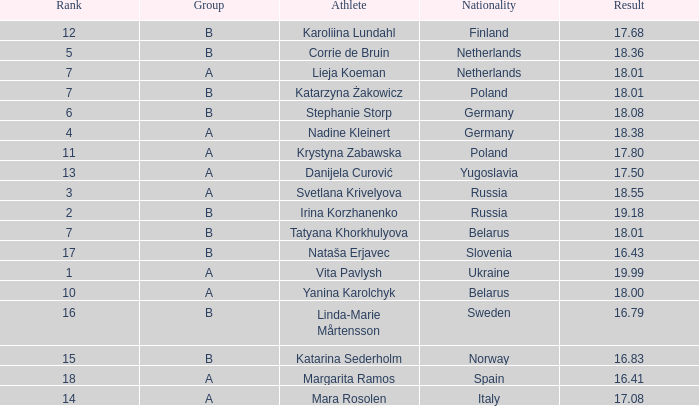What is the average rank for Group A athlete Yanina Karolchyk, and a result higher than 18? None. 